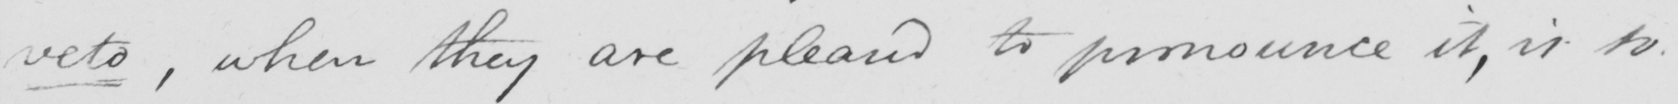What is written in this line of handwriting? veto, when they are pleased to pronounce it, is so 